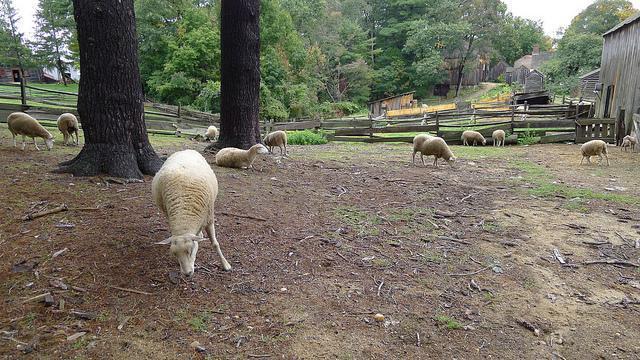How many tree trunks do you see?
Give a very brief answer. 2. 